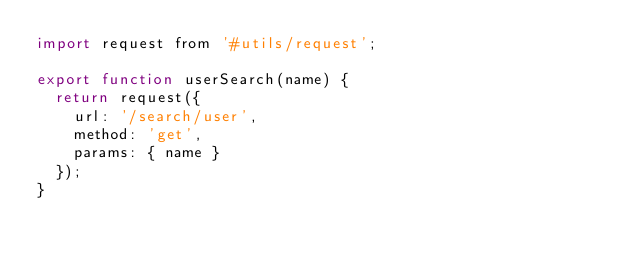Convert code to text. <code><loc_0><loc_0><loc_500><loc_500><_JavaScript_>import request from '#utils/request';

export function userSearch(name) {
  return request({
    url: '/search/user',
    method: 'get',
    params: { name }
  });
}
</code> 